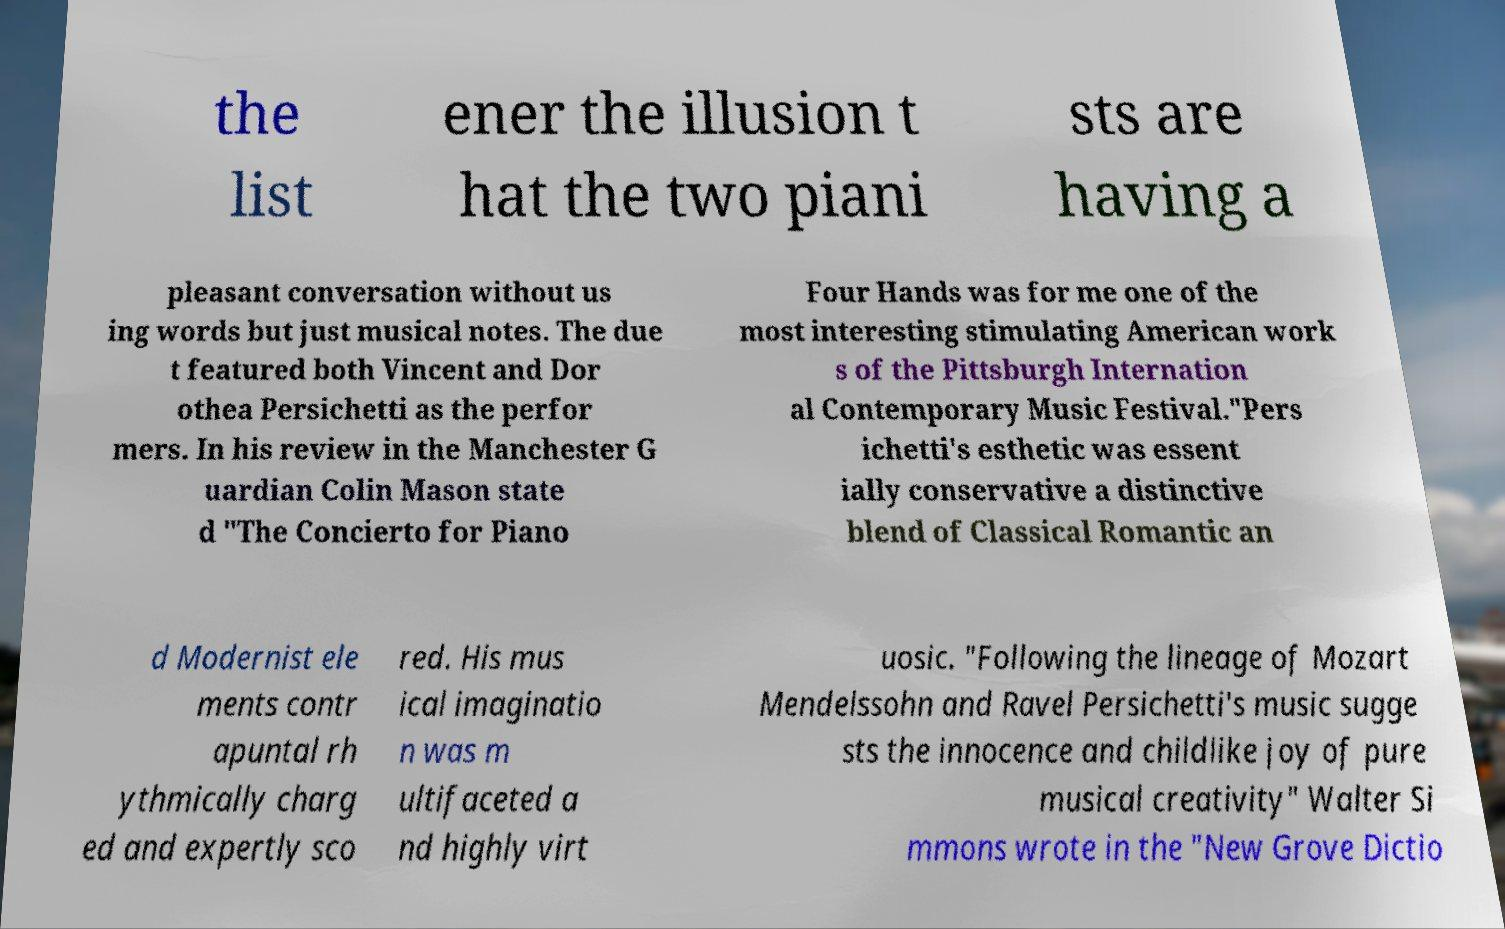Please identify and transcribe the text found in this image. the list ener the illusion t hat the two piani sts are having a pleasant conversation without us ing words but just musical notes. The due t featured both Vincent and Dor othea Persichetti as the perfor mers. In his review in the Manchester G uardian Colin Mason state d "The Concierto for Piano Four Hands was for me one of the most interesting stimulating American work s of the Pittsburgh Internation al Contemporary Music Festival."Pers ichetti's esthetic was essent ially conservative a distinctive blend of Classical Romantic an d Modernist ele ments contr apuntal rh ythmically charg ed and expertly sco red. His mus ical imaginatio n was m ultifaceted a nd highly virt uosic. "Following the lineage of Mozart Mendelssohn and Ravel Persichetti's music sugge sts the innocence and childlike joy of pure musical creativity" Walter Si mmons wrote in the "New Grove Dictio 